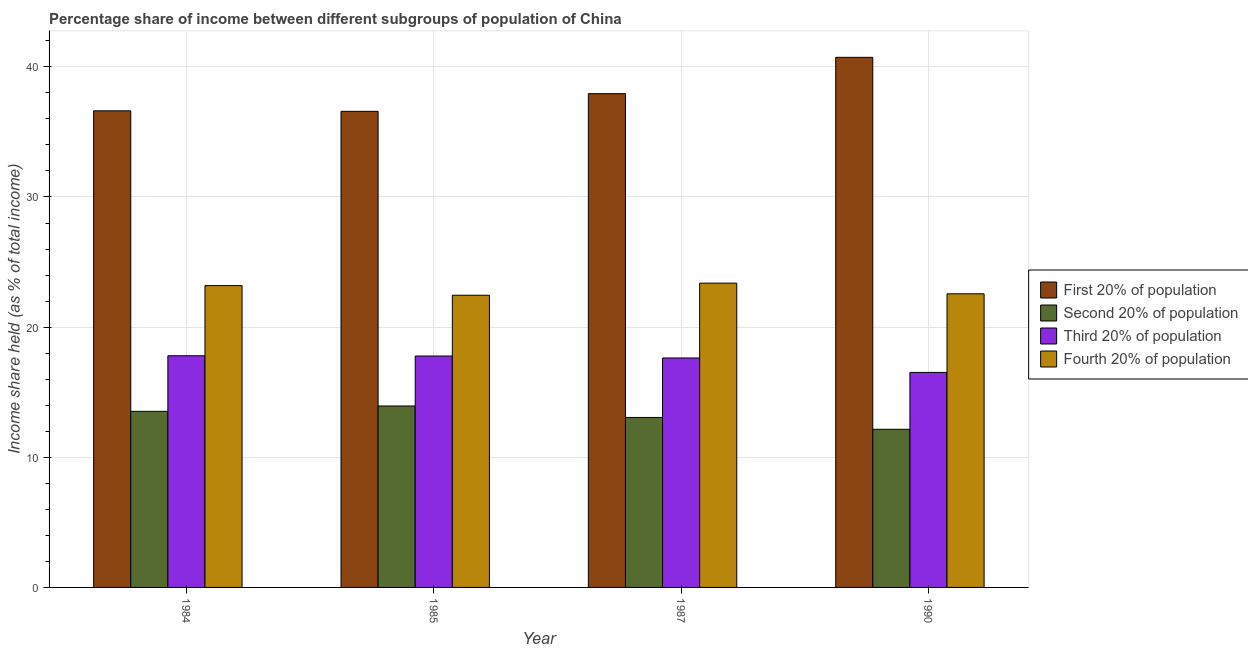Are the number of bars per tick equal to the number of legend labels?
Your response must be concise. Yes. How many bars are there on the 3rd tick from the left?
Your response must be concise. 4. How many bars are there on the 2nd tick from the right?
Provide a succinct answer. 4. In how many cases, is the number of bars for a given year not equal to the number of legend labels?
Provide a short and direct response. 0. What is the share of the income held by third 20% of the population in 1985?
Make the answer very short. 17.78. Across all years, what is the minimum share of the income held by first 20% of the population?
Give a very brief answer. 36.58. In which year was the share of the income held by second 20% of the population maximum?
Offer a terse response. 1985. In which year was the share of the income held by first 20% of the population minimum?
Offer a terse response. 1985. What is the total share of the income held by third 20% of the population in the graph?
Offer a terse response. 69.73. What is the difference between the share of the income held by third 20% of the population in 1985 and that in 1990?
Ensure brevity in your answer.  1.26. What is the difference between the share of the income held by second 20% of the population in 1985 and the share of the income held by first 20% of the population in 1987?
Provide a succinct answer. 0.88. What is the average share of the income held by first 20% of the population per year?
Offer a very short reply. 37.97. What is the ratio of the share of the income held by third 20% of the population in 1984 to that in 1985?
Keep it short and to the point. 1. What is the difference between the highest and the second highest share of the income held by third 20% of the population?
Your response must be concise. 0.02. What is the difference between the highest and the lowest share of the income held by fourth 20% of the population?
Keep it short and to the point. 0.93. In how many years, is the share of the income held by second 20% of the population greater than the average share of the income held by second 20% of the population taken over all years?
Give a very brief answer. 2. What does the 4th bar from the left in 1985 represents?
Ensure brevity in your answer.  Fourth 20% of population. What does the 2nd bar from the right in 1985 represents?
Keep it short and to the point. Third 20% of population. Is it the case that in every year, the sum of the share of the income held by first 20% of the population and share of the income held by second 20% of the population is greater than the share of the income held by third 20% of the population?
Provide a succinct answer. Yes. How many bars are there?
Give a very brief answer. 16. Are all the bars in the graph horizontal?
Give a very brief answer. No. Does the graph contain any zero values?
Give a very brief answer. No. How many legend labels are there?
Make the answer very short. 4. What is the title of the graph?
Your answer should be compact. Percentage share of income between different subgroups of population of China. Does "Arable land" appear as one of the legend labels in the graph?
Keep it short and to the point. No. What is the label or title of the Y-axis?
Make the answer very short. Income share held (as % of total income). What is the Income share held (as % of total income) in First 20% of population in 1984?
Provide a short and direct response. 36.62. What is the Income share held (as % of total income) of Second 20% of population in 1984?
Give a very brief answer. 13.53. What is the Income share held (as % of total income) of Third 20% of population in 1984?
Keep it short and to the point. 17.8. What is the Income share held (as % of total income) of Fourth 20% of population in 1984?
Ensure brevity in your answer.  23.19. What is the Income share held (as % of total income) of First 20% of population in 1985?
Ensure brevity in your answer.  36.58. What is the Income share held (as % of total income) in Second 20% of population in 1985?
Give a very brief answer. 13.94. What is the Income share held (as % of total income) in Third 20% of population in 1985?
Make the answer very short. 17.78. What is the Income share held (as % of total income) of Fourth 20% of population in 1985?
Provide a short and direct response. 22.45. What is the Income share held (as % of total income) in First 20% of population in 1987?
Ensure brevity in your answer.  37.94. What is the Income share held (as % of total income) in Second 20% of population in 1987?
Offer a terse response. 13.06. What is the Income share held (as % of total income) of Third 20% of population in 1987?
Ensure brevity in your answer.  17.63. What is the Income share held (as % of total income) in Fourth 20% of population in 1987?
Offer a very short reply. 23.38. What is the Income share held (as % of total income) in First 20% of population in 1990?
Your answer should be compact. 40.73. What is the Income share held (as % of total income) in Second 20% of population in 1990?
Provide a succinct answer. 12.15. What is the Income share held (as % of total income) in Third 20% of population in 1990?
Your answer should be very brief. 16.52. What is the Income share held (as % of total income) of Fourth 20% of population in 1990?
Your answer should be very brief. 22.56. Across all years, what is the maximum Income share held (as % of total income) in First 20% of population?
Provide a short and direct response. 40.73. Across all years, what is the maximum Income share held (as % of total income) of Second 20% of population?
Offer a terse response. 13.94. Across all years, what is the maximum Income share held (as % of total income) in Fourth 20% of population?
Your answer should be very brief. 23.38. Across all years, what is the minimum Income share held (as % of total income) in First 20% of population?
Your answer should be very brief. 36.58. Across all years, what is the minimum Income share held (as % of total income) in Second 20% of population?
Ensure brevity in your answer.  12.15. Across all years, what is the minimum Income share held (as % of total income) of Third 20% of population?
Offer a very short reply. 16.52. Across all years, what is the minimum Income share held (as % of total income) in Fourth 20% of population?
Make the answer very short. 22.45. What is the total Income share held (as % of total income) in First 20% of population in the graph?
Ensure brevity in your answer.  151.87. What is the total Income share held (as % of total income) in Second 20% of population in the graph?
Provide a short and direct response. 52.68. What is the total Income share held (as % of total income) in Third 20% of population in the graph?
Give a very brief answer. 69.73. What is the total Income share held (as % of total income) in Fourth 20% of population in the graph?
Your answer should be compact. 91.58. What is the difference between the Income share held (as % of total income) of First 20% of population in 1984 and that in 1985?
Your answer should be very brief. 0.04. What is the difference between the Income share held (as % of total income) of Second 20% of population in 1984 and that in 1985?
Your response must be concise. -0.41. What is the difference between the Income share held (as % of total income) of Third 20% of population in 1984 and that in 1985?
Offer a terse response. 0.02. What is the difference between the Income share held (as % of total income) in Fourth 20% of population in 1984 and that in 1985?
Offer a very short reply. 0.74. What is the difference between the Income share held (as % of total income) of First 20% of population in 1984 and that in 1987?
Give a very brief answer. -1.32. What is the difference between the Income share held (as % of total income) of Second 20% of population in 1984 and that in 1987?
Offer a terse response. 0.47. What is the difference between the Income share held (as % of total income) of Third 20% of population in 1984 and that in 1987?
Your answer should be very brief. 0.17. What is the difference between the Income share held (as % of total income) of Fourth 20% of population in 1984 and that in 1987?
Make the answer very short. -0.19. What is the difference between the Income share held (as % of total income) of First 20% of population in 1984 and that in 1990?
Provide a short and direct response. -4.11. What is the difference between the Income share held (as % of total income) of Second 20% of population in 1984 and that in 1990?
Your answer should be very brief. 1.38. What is the difference between the Income share held (as % of total income) in Third 20% of population in 1984 and that in 1990?
Keep it short and to the point. 1.28. What is the difference between the Income share held (as % of total income) of Fourth 20% of population in 1984 and that in 1990?
Your answer should be compact. 0.63. What is the difference between the Income share held (as % of total income) in First 20% of population in 1985 and that in 1987?
Offer a very short reply. -1.36. What is the difference between the Income share held (as % of total income) in Third 20% of population in 1985 and that in 1987?
Offer a very short reply. 0.15. What is the difference between the Income share held (as % of total income) in Fourth 20% of population in 1985 and that in 1987?
Make the answer very short. -0.93. What is the difference between the Income share held (as % of total income) of First 20% of population in 1985 and that in 1990?
Give a very brief answer. -4.15. What is the difference between the Income share held (as % of total income) of Second 20% of population in 1985 and that in 1990?
Give a very brief answer. 1.79. What is the difference between the Income share held (as % of total income) in Third 20% of population in 1985 and that in 1990?
Your response must be concise. 1.26. What is the difference between the Income share held (as % of total income) in Fourth 20% of population in 1985 and that in 1990?
Ensure brevity in your answer.  -0.11. What is the difference between the Income share held (as % of total income) of First 20% of population in 1987 and that in 1990?
Offer a terse response. -2.79. What is the difference between the Income share held (as % of total income) in Second 20% of population in 1987 and that in 1990?
Provide a succinct answer. 0.91. What is the difference between the Income share held (as % of total income) in Third 20% of population in 1987 and that in 1990?
Offer a very short reply. 1.11. What is the difference between the Income share held (as % of total income) of Fourth 20% of population in 1987 and that in 1990?
Your answer should be very brief. 0.82. What is the difference between the Income share held (as % of total income) of First 20% of population in 1984 and the Income share held (as % of total income) of Second 20% of population in 1985?
Offer a terse response. 22.68. What is the difference between the Income share held (as % of total income) of First 20% of population in 1984 and the Income share held (as % of total income) of Third 20% of population in 1985?
Offer a very short reply. 18.84. What is the difference between the Income share held (as % of total income) in First 20% of population in 1984 and the Income share held (as % of total income) in Fourth 20% of population in 1985?
Offer a terse response. 14.17. What is the difference between the Income share held (as % of total income) of Second 20% of population in 1984 and the Income share held (as % of total income) of Third 20% of population in 1985?
Ensure brevity in your answer.  -4.25. What is the difference between the Income share held (as % of total income) in Second 20% of population in 1984 and the Income share held (as % of total income) in Fourth 20% of population in 1985?
Your answer should be compact. -8.92. What is the difference between the Income share held (as % of total income) of Third 20% of population in 1984 and the Income share held (as % of total income) of Fourth 20% of population in 1985?
Your answer should be compact. -4.65. What is the difference between the Income share held (as % of total income) of First 20% of population in 1984 and the Income share held (as % of total income) of Second 20% of population in 1987?
Give a very brief answer. 23.56. What is the difference between the Income share held (as % of total income) in First 20% of population in 1984 and the Income share held (as % of total income) in Third 20% of population in 1987?
Your answer should be very brief. 18.99. What is the difference between the Income share held (as % of total income) in First 20% of population in 1984 and the Income share held (as % of total income) in Fourth 20% of population in 1987?
Your response must be concise. 13.24. What is the difference between the Income share held (as % of total income) in Second 20% of population in 1984 and the Income share held (as % of total income) in Third 20% of population in 1987?
Your answer should be compact. -4.1. What is the difference between the Income share held (as % of total income) of Second 20% of population in 1984 and the Income share held (as % of total income) of Fourth 20% of population in 1987?
Keep it short and to the point. -9.85. What is the difference between the Income share held (as % of total income) of Third 20% of population in 1984 and the Income share held (as % of total income) of Fourth 20% of population in 1987?
Your answer should be compact. -5.58. What is the difference between the Income share held (as % of total income) of First 20% of population in 1984 and the Income share held (as % of total income) of Second 20% of population in 1990?
Your answer should be compact. 24.47. What is the difference between the Income share held (as % of total income) in First 20% of population in 1984 and the Income share held (as % of total income) in Third 20% of population in 1990?
Keep it short and to the point. 20.1. What is the difference between the Income share held (as % of total income) in First 20% of population in 1984 and the Income share held (as % of total income) in Fourth 20% of population in 1990?
Keep it short and to the point. 14.06. What is the difference between the Income share held (as % of total income) of Second 20% of population in 1984 and the Income share held (as % of total income) of Third 20% of population in 1990?
Ensure brevity in your answer.  -2.99. What is the difference between the Income share held (as % of total income) in Second 20% of population in 1984 and the Income share held (as % of total income) in Fourth 20% of population in 1990?
Make the answer very short. -9.03. What is the difference between the Income share held (as % of total income) of Third 20% of population in 1984 and the Income share held (as % of total income) of Fourth 20% of population in 1990?
Offer a terse response. -4.76. What is the difference between the Income share held (as % of total income) of First 20% of population in 1985 and the Income share held (as % of total income) of Second 20% of population in 1987?
Offer a very short reply. 23.52. What is the difference between the Income share held (as % of total income) of First 20% of population in 1985 and the Income share held (as % of total income) of Third 20% of population in 1987?
Keep it short and to the point. 18.95. What is the difference between the Income share held (as % of total income) in First 20% of population in 1985 and the Income share held (as % of total income) in Fourth 20% of population in 1987?
Ensure brevity in your answer.  13.2. What is the difference between the Income share held (as % of total income) in Second 20% of population in 1985 and the Income share held (as % of total income) in Third 20% of population in 1987?
Your answer should be very brief. -3.69. What is the difference between the Income share held (as % of total income) in Second 20% of population in 1985 and the Income share held (as % of total income) in Fourth 20% of population in 1987?
Provide a short and direct response. -9.44. What is the difference between the Income share held (as % of total income) in First 20% of population in 1985 and the Income share held (as % of total income) in Second 20% of population in 1990?
Offer a terse response. 24.43. What is the difference between the Income share held (as % of total income) in First 20% of population in 1985 and the Income share held (as % of total income) in Third 20% of population in 1990?
Ensure brevity in your answer.  20.06. What is the difference between the Income share held (as % of total income) in First 20% of population in 1985 and the Income share held (as % of total income) in Fourth 20% of population in 1990?
Your answer should be compact. 14.02. What is the difference between the Income share held (as % of total income) in Second 20% of population in 1985 and the Income share held (as % of total income) in Third 20% of population in 1990?
Offer a terse response. -2.58. What is the difference between the Income share held (as % of total income) of Second 20% of population in 1985 and the Income share held (as % of total income) of Fourth 20% of population in 1990?
Make the answer very short. -8.62. What is the difference between the Income share held (as % of total income) in Third 20% of population in 1985 and the Income share held (as % of total income) in Fourth 20% of population in 1990?
Keep it short and to the point. -4.78. What is the difference between the Income share held (as % of total income) in First 20% of population in 1987 and the Income share held (as % of total income) in Second 20% of population in 1990?
Give a very brief answer. 25.79. What is the difference between the Income share held (as % of total income) of First 20% of population in 1987 and the Income share held (as % of total income) of Third 20% of population in 1990?
Make the answer very short. 21.42. What is the difference between the Income share held (as % of total income) of First 20% of population in 1987 and the Income share held (as % of total income) of Fourth 20% of population in 1990?
Ensure brevity in your answer.  15.38. What is the difference between the Income share held (as % of total income) in Second 20% of population in 1987 and the Income share held (as % of total income) in Third 20% of population in 1990?
Keep it short and to the point. -3.46. What is the difference between the Income share held (as % of total income) of Third 20% of population in 1987 and the Income share held (as % of total income) of Fourth 20% of population in 1990?
Your response must be concise. -4.93. What is the average Income share held (as % of total income) of First 20% of population per year?
Provide a succinct answer. 37.97. What is the average Income share held (as % of total income) in Second 20% of population per year?
Keep it short and to the point. 13.17. What is the average Income share held (as % of total income) of Third 20% of population per year?
Offer a very short reply. 17.43. What is the average Income share held (as % of total income) of Fourth 20% of population per year?
Provide a short and direct response. 22.89. In the year 1984, what is the difference between the Income share held (as % of total income) in First 20% of population and Income share held (as % of total income) in Second 20% of population?
Provide a short and direct response. 23.09. In the year 1984, what is the difference between the Income share held (as % of total income) in First 20% of population and Income share held (as % of total income) in Third 20% of population?
Keep it short and to the point. 18.82. In the year 1984, what is the difference between the Income share held (as % of total income) in First 20% of population and Income share held (as % of total income) in Fourth 20% of population?
Keep it short and to the point. 13.43. In the year 1984, what is the difference between the Income share held (as % of total income) in Second 20% of population and Income share held (as % of total income) in Third 20% of population?
Offer a very short reply. -4.27. In the year 1984, what is the difference between the Income share held (as % of total income) in Second 20% of population and Income share held (as % of total income) in Fourth 20% of population?
Make the answer very short. -9.66. In the year 1984, what is the difference between the Income share held (as % of total income) of Third 20% of population and Income share held (as % of total income) of Fourth 20% of population?
Ensure brevity in your answer.  -5.39. In the year 1985, what is the difference between the Income share held (as % of total income) of First 20% of population and Income share held (as % of total income) of Second 20% of population?
Your response must be concise. 22.64. In the year 1985, what is the difference between the Income share held (as % of total income) in First 20% of population and Income share held (as % of total income) in Third 20% of population?
Give a very brief answer. 18.8. In the year 1985, what is the difference between the Income share held (as % of total income) of First 20% of population and Income share held (as % of total income) of Fourth 20% of population?
Provide a succinct answer. 14.13. In the year 1985, what is the difference between the Income share held (as % of total income) in Second 20% of population and Income share held (as % of total income) in Third 20% of population?
Give a very brief answer. -3.84. In the year 1985, what is the difference between the Income share held (as % of total income) of Second 20% of population and Income share held (as % of total income) of Fourth 20% of population?
Provide a succinct answer. -8.51. In the year 1985, what is the difference between the Income share held (as % of total income) in Third 20% of population and Income share held (as % of total income) in Fourth 20% of population?
Your answer should be very brief. -4.67. In the year 1987, what is the difference between the Income share held (as % of total income) of First 20% of population and Income share held (as % of total income) of Second 20% of population?
Provide a short and direct response. 24.88. In the year 1987, what is the difference between the Income share held (as % of total income) in First 20% of population and Income share held (as % of total income) in Third 20% of population?
Provide a succinct answer. 20.31. In the year 1987, what is the difference between the Income share held (as % of total income) of First 20% of population and Income share held (as % of total income) of Fourth 20% of population?
Make the answer very short. 14.56. In the year 1987, what is the difference between the Income share held (as % of total income) in Second 20% of population and Income share held (as % of total income) in Third 20% of population?
Offer a very short reply. -4.57. In the year 1987, what is the difference between the Income share held (as % of total income) in Second 20% of population and Income share held (as % of total income) in Fourth 20% of population?
Your answer should be very brief. -10.32. In the year 1987, what is the difference between the Income share held (as % of total income) of Third 20% of population and Income share held (as % of total income) of Fourth 20% of population?
Ensure brevity in your answer.  -5.75. In the year 1990, what is the difference between the Income share held (as % of total income) in First 20% of population and Income share held (as % of total income) in Second 20% of population?
Ensure brevity in your answer.  28.58. In the year 1990, what is the difference between the Income share held (as % of total income) of First 20% of population and Income share held (as % of total income) of Third 20% of population?
Your response must be concise. 24.21. In the year 1990, what is the difference between the Income share held (as % of total income) of First 20% of population and Income share held (as % of total income) of Fourth 20% of population?
Your response must be concise. 18.17. In the year 1990, what is the difference between the Income share held (as % of total income) of Second 20% of population and Income share held (as % of total income) of Third 20% of population?
Provide a succinct answer. -4.37. In the year 1990, what is the difference between the Income share held (as % of total income) in Second 20% of population and Income share held (as % of total income) in Fourth 20% of population?
Your response must be concise. -10.41. In the year 1990, what is the difference between the Income share held (as % of total income) in Third 20% of population and Income share held (as % of total income) in Fourth 20% of population?
Your answer should be very brief. -6.04. What is the ratio of the Income share held (as % of total income) in Second 20% of population in 1984 to that in 1985?
Ensure brevity in your answer.  0.97. What is the ratio of the Income share held (as % of total income) of Third 20% of population in 1984 to that in 1985?
Give a very brief answer. 1. What is the ratio of the Income share held (as % of total income) in Fourth 20% of population in 1984 to that in 1985?
Your answer should be very brief. 1.03. What is the ratio of the Income share held (as % of total income) of First 20% of population in 1984 to that in 1987?
Ensure brevity in your answer.  0.97. What is the ratio of the Income share held (as % of total income) of Second 20% of population in 1984 to that in 1987?
Provide a short and direct response. 1.04. What is the ratio of the Income share held (as % of total income) in Third 20% of population in 1984 to that in 1987?
Give a very brief answer. 1.01. What is the ratio of the Income share held (as % of total income) in First 20% of population in 1984 to that in 1990?
Make the answer very short. 0.9. What is the ratio of the Income share held (as % of total income) in Second 20% of population in 1984 to that in 1990?
Offer a terse response. 1.11. What is the ratio of the Income share held (as % of total income) in Third 20% of population in 1984 to that in 1990?
Offer a very short reply. 1.08. What is the ratio of the Income share held (as % of total income) of Fourth 20% of population in 1984 to that in 1990?
Offer a terse response. 1.03. What is the ratio of the Income share held (as % of total income) in First 20% of population in 1985 to that in 1987?
Offer a very short reply. 0.96. What is the ratio of the Income share held (as % of total income) in Second 20% of population in 1985 to that in 1987?
Keep it short and to the point. 1.07. What is the ratio of the Income share held (as % of total income) in Third 20% of population in 1985 to that in 1987?
Offer a very short reply. 1.01. What is the ratio of the Income share held (as % of total income) in Fourth 20% of population in 1985 to that in 1987?
Make the answer very short. 0.96. What is the ratio of the Income share held (as % of total income) of First 20% of population in 1985 to that in 1990?
Keep it short and to the point. 0.9. What is the ratio of the Income share held (as % of total income) in Second 20% of population in 1985 to that in 1990?
Your answer should be very brief. 1.15. What is the ratio of the Income share held (as % of total income) of Third 20% of population in 1985 to that in 1990?
Your answer should be compact. 1.08. What is the ratio of the Income share held (as % of total income) in First 20% of population in 1987 to that in 1990?
Provide a short and direct response. 0.93. What is the ratio of the Income share held (as % of total income) in Second 20% of population in 1987 to that in 1990?
Keep it short and to the point. 1.07. What is the ratio of the Income share held (as % of total income) of Third 20% of population in 1987 to that in 1990?
Keep it short and to the point. 1.07. What is the ratio of the Income share held (as % of total income) of Fourth 20% of population in 1987 to that in 1990?
Offer a terse response. 1.04. What is the difference between the highest and the second highest Income share held (as % of total income) in First 20% of population?
Offer a very short reply. 2.79. What is the difference between the highest and the second highest Income share held (as % of total income) of Second 20% of population?
Your answer should be compact. 0.41. What is the difference between the highest and the second highest Income share held (as % of total income) of Third 20% of population?
Your answer should be compact. 0.02. What is the difference between the highest and the second highest Income share held (as % of total income) of Fourth 20% of population?
Provide a succinct answer. 0.19. What is the difference between the highest and the lowest Income share held (as % of total income) of First 20% of population?
Provide a short and direct response. 4.15. What is the difference between the highest and the lowest Income share held (as % of total income) in Second 20% of population?
Give a very brief answer. 1.79. What is the difference between the highest and the lowest Income share held (as % of total income) in Third 20% of population?
Keep it short and to the point. 1.28. 